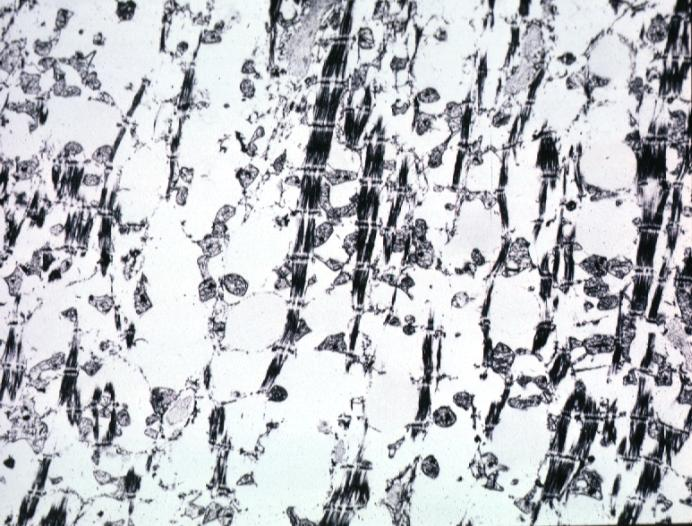what does lesion of myocytolysis contain?
Answer the question using a single word or phrase. Not lipid 